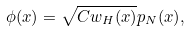Convert formula to latex. <formula><loc_0><loc_0><loc_500><loc_500>\phi ( x ) = \sqrt { C w _ { H } ( x ) } p _ { N } ( x ) ,</formula> 